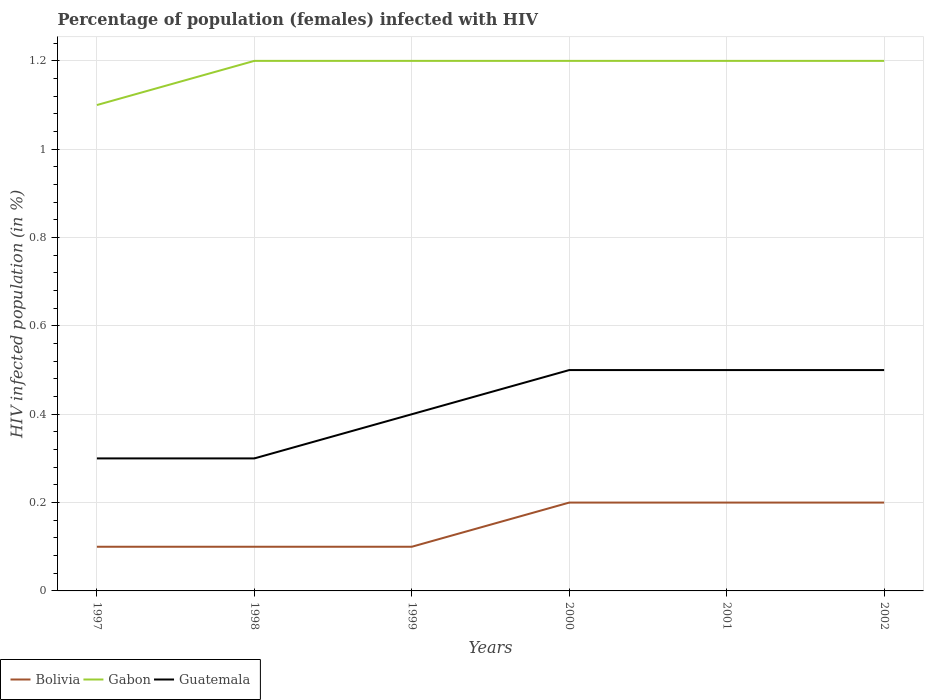Does the line corresponding to Gabon intersect with the line corresponding to Bolivia?
Your answer should be compact. No. Across all years, what is the maximum percentage of HIV infected female population in Guatemala?
Your answer should be very brief. 0.3. In which year was the percentage of HIV infected female population in Guatemala maximum?
Offer a very short reply. 1997. What is the difference between the highest and the lowest percentage of HIV infected female population in Bolivia?
Provide a short and direct response. 3. Are the values on the major ticks of Y-axis written in scientific E-notation?
Give a very brief answer. No. Does the graph contain any zero values?
Make the answer very short. No. Does the graph contain grids?
Give a very brief answer. Yes. How many legend labels are there?
Give a very brief answer. 3. What is the title of the graph?
Give a very brief answer. Percentage of population (females) infected with HIV. What is the label or title of the Y-axis?
Provide a succinct answer. HIV infected population (in %). What is the HIV infected population (in %) in Bolivia in 1997?
Make the answer very short. 0.1. What is the HIV infected population (in %) of Gabon in 1997?
Keep it short and to the point. 1.1. What is the HIV infected population (in %) of Guatemala in 1997?
Make the answer very short. 0.3. What is the HIV infected population (in %) of Gabon in 1998?
Ensure brevity in your answer.  1.2. What is the HIV infected population (in %) in Gabon in 1999?
Make the answer very short. 1.2. What is the HIV infected population (in %) of Guatemala in 1999?
Your answer should be compact. 0.4. What is the HIV infected population (in %) of Gabon in 2000?
Provide a short and direct response. 1.2. What is the HIV infected population (in %) in Guatemala in 2000?
Your answer should be very brief. 0.5. What is the HIV infected population (in %) of Bolivia in 2001?
Offer a terse response. 0.2. What is the HIV infected population (in %) in Bolivia in 2002?
Keep it short and to the point. 0.2. Across all years, what is the maximum HIV infected population (in %) in Bolivia?
Your answer should be very brief. 0.2. Across all years, what is the maximum HIV infected population (in %) in Guatemala?
Offer a terse response. 0.5. Across all years, what is the minimum HIV infected population (in %) in Bolivia?
Make the answer very short. 0.1. Across all years, what is the minimum HIV infected population (in %) of Gabon?
Provide a succinct answer. 1.1. Across all years, what is the minimum HIV infected population (in %) in Guatemala?
Keep it short and to the point. 0.3. What is the total HIV infected population (in %) in Bolivia in the graph?
Provide a short and direct response. 0.9. What is the total HIV infected population (in %) of Guatemala in the graph?
Provide a succinct answer. 2.5. What is the difference between the HIV infected population (in %) of Bolivia in 1997 and that in 1998?
Ensure brevity in your answer.  0. What is the difference between the HIV infected population (in %) in Gabon in 1997 and that in 1998?
Your answer should be very brief. -0.1. What is the difference between the HIV infected population (in %) in Gabon in 1997 and that in 2000?
Provide a succinct answer. -0.1. What is the difference between the HIV infected population (in %) of Guatemala in 1997 and that in 2000?
Offer a terse response. -0.2. What is the difference between the HIV infected population (in %) in Bolivia in 1997 and that in 2001?
Offer a terse response. -0.1. What is the difference between the HIV infected population (in %) in Gabon in 1997 and that in 2001?
Ensure brevity in your answer.  -0.1. What is the difference between the HIV infected population (in %) of Guatemala in 1997 and that in 2001?
Make the answer very short. -0.2. What is the difference between the HIV infected population (in %) of Gabon in 1997 and that in 2002?
Give a very brief answer. -0.1. What is the difference between the HIV infected population (in %) in Gabon in 1998 and that in 1999?
Your response must be concise. 0. What is the difference between the HIV infected population (in %) of Guatemala in 1998 and that in 1999?
Offer a terse response. -0.1. What is the difference between the HIV infected population (in %) of Bolivia in 1998 and that in 2000?
Keep it short and to the point. -0.1. What is the difference between the HIV infected population (in %) of Bolivia in 1998 and that in 2001?
Your answer should be compact. -0.1. What is the difference between the HIV infected population (in %) of Gabon in 1998 and that in 2001?
Make the answer very short. 0. What is the difference between the HIV infected population (in %) of Guatemala in 1998 and that in 2001?
Offer a very short reply. -0.2. What is the difference between the HIV infected population (in %) of Bolivia in 1998 and that in 2002?
Make the answer very short. -0.1. What is the difference between the HIV infected population (in %) in Gabon in 1999 and that in 2001?
Offer a very short reply. 0. What is the difference between the HIV infected population (in %) of Guatemala in 1999 and that in 2001?
Offer a terse response. -0.1. What is the difference between the HIV infected population (in %) in Bolivia in 1999 and that in 2002?
Your answer should be very brief. -0.1. What is the difference between the HIV infected population (in %) in Gabon in 1999 and that in 2002?
Offer a terse response. 0. What is the difference between the HIV infected population (in %) in Gabon in 2000 and that in 2001?
Offer a very short reply. 0. What is the difference between the HIV infected population (in %) of Gabon in 2000 and that in 2002?
Provide a short and direct response. 0. What is the difference between the HIV infected population (in %) in Gabon in 2001 and that in 2002?
Provide a succinct answer. 0. What is the difference between the HIV infected population (in %) in Guatemala in 2001 and that in 2002?
Your answer should be compact. 0. What is the difference between the HIV infected population (in %) of Bolivia in 1997 and the HIV infected population (in %) of Gabon in 1998?
Offer a very short reply. -1.1. What is the difference between the HIV infected population (in %) of Bolivia in 1997 and the HIV infected population (in %) of Gabon in 1999?
Offer a very short reply. -1.1. What is the difference between the HIV infected population (in %) in Bolivia in 1997 and the HIV infected population (in %) in Guatemala in 1999?
Provide a short and direct response. -0.3. What is the difference between the HIV infected population (in %) in Gabon in 1997 and the HIV infected population (in %) in Guatemala in 2000?
Your answer should be very brief. 0.6. What is the difference between the HIV infected population (in %) of Bolivia in 1997 and the HIV infected population (in %) of Gabon in 2001?
Your answer should be very brief. -1.1. What is the difference between the HIV infected population (in %) of Bolivia in 1997 and the HIV infected population (in %) of Guatemala in 2001?
Keep it short and to the point. -0.4. What is the difference between the HIV infected population (in %) in Gabon in 1997 and the HIV infected population (in %) in Guatemala in 2001?
Give a very brief answer. 0.6. What is the difference between the HIV infected population (in %) of Bolivia in 1997 and the HIV infected population (in %) of Gabon in 2002?
Provide a succinct answer. -1.1. What is the difference between the HIV infected population (in %) of Bolivia in 1997 and the HIV infected population (in %) of Guatemala in 2002?
Ensure brevity in your answer.  -0.4. What is the difference between the HIV infected population (in %) of Bolivia in 1998 and the HIV infected population (in %) of Guatemala in 1999?
Your answer should be compact. -0.3. What is the difference between the HIV infected population (in %) in Bolivia in 1998 and the HIV infected population (in %) in Gabon in 2000?
Provide a short and direct response. -1.1. What is the difference between the HIV infected population (in %) in Bolivia in 1998 and the HIV infected population (in %) in Guatemala in 2000?
Give a very brief answer. -0.4. What is the difference between the HIV infected population (in %) of Bolivia in 1998 and the HIV infected population (in %) of Gabon in 2002?
Your response must be concise. -1.1. What is the difference between the HIV infected population (in %) of Gabon in 1999 and the HIV infected population (in %) of Guatemala in 2000?
Give a very brief answer. 0.7. What is the difference between the HIV infected population (in %) in Bolivia in 1999 and the HIV infected population (in %) in Gabon in 2001?
Offer a terse response. -1.1. What is the difference between the HIV infected population (in %) in Gabon in 1999 and the HIV infected population (in %) in Guatemala in 2001?
Offer a terse response. 0.7. What is the difference between the HIV infected population (in %) in Bolivia in 1999 and the HIV infected population (in %) in Gabon in 2002?
Ensure brevity in your answer.  -1.1. What is the difference between the HIV infected population (in %) of Bolivia in 2000 and the HIV infected population (in %) of Gabon in 2001?
Offer a terse response. -1. What is the difference between the HIV infected population (in %) of Bolivia in 2000 and the HIV infected population (in %) of Guatemala in 2001?
Provide a succinct answer. -0.3. What is the difference between the HIV infected population (in %) of Gabon in 2000 and the HIV infected population (in %) of Guatemala in 2001?
Ensure brevity in your answer.  0.7. What is the difference between the HIV infected population (in %) in Bolivia in 2000 and the HIV infected population (in %) in Guatemala in 2002?
Offer a very short reply. -0.3. What is the difference between the HIV infected population (in %) in Gabon in 2000 and the HIV infected population (in %) in Guatemala in 2002?
Your answer should be very brief. 0.7. What is the difference between the HIV infected population (in %) of Bolivia in 2001 and the HIV infected population (in %) of Gabon in 2002?
Offer a very short reply. -1. What is the difference between the HIV infected population (in %) of Bolivia in 2001 and the HIV infected population (in %) of Guatemala in 2002?
Offer a terse response. -0.3. What is the average HIV infected population (in %) of Bolivia per year?
Make the answer very short. 0.15. What is the average HIV infected population (in %) in Gabon per year?
Ensure brevity in your answer.  1.18. What is the average HIV infected population (in %) in Guatemala per year?
Offer a terse response. 0.42. In the year 1997, what is the difference between the HIV infected population (in %) in Bolivia and HIV infected population (in %) in Gabon?
Your answer should be compact. -1. In the year 1997, what is the difference between the HIV infected population (in %) of Gabon and HIV infected population (in %) of Guatemala?
Your answer should be compact. 0.8. In the year 1998, what is the difference between the HIV infected population (in %) in Bolivia and HIV infected population (in %) in Gabon?
Your answer should be compact. -1.1. In the year 1998, what is the difference between the HIV infected population (in %) of Bolivia and HIV infected population (in %) of Guatemala?
Your answer should be compact. -0.2. In the year 1999, what is the difference between the HIV infected population (in %) in Bolivia and HIV infected population (in %) in Guatemala?
Provide a succinct answer. -0.3. In the year 2000, what is the difference between the HIV infected population (in %) in Bolivia and HIV infected population (in %) in Gabon?
Provide a short and direct response. -1. In the year 2000, what is the difference between the HIV infected population (in %) of Bolivia and HIV infected population (in %) of Guatemala?
Give a very brief answer. -0.3. In the year 2000, what is the difference between the HIV infected population (in %) in Gabon and HIV infected population (in %) in Guatemala?
Ensure brevity in your answer.  0.7. In the year 2001, what is the difference between the HIV infected population (in %) in Bolivia and HIV infected population (in %) in Gabon?
Offer a very short reply. -1. In the year 2001, what is the difference between the HIV infected population (in %) of Bolivia and HIV infected population (in %) of Guatemala?
Offer a terse response. -0.3. In the year 2001, what is the difference between the HIV infected population (in %) of Gabon and HIV infected population (in %) of Guatemala?
Your response must be concise. 0.7. In the year 2002, what is the difference between the HIV infected population (in %) of Bolivia and HIV infected population (in %) of Gabon?
Offer a very short reply. -1. In the year 2002, what is the difference between the HIV infected population (in %) of Bolivia and HIV infected population (in %) of Guatemala?
Ensure brevity in your answer.  -0.3. What is the ratio of the HIV infected population (in %) in Bolivia in 1997 to that in 1998?
Your answer should be very brief. 1. What is the ratio of the HIV infected population (in %) in Guatemala in 1997 to that in 1998?
Ensure brevity in your answer.  1. What is the ratio of the HIV infected population (in %) in Bolivia in 1997 to that in 1999?
Your response must be concise. 1. What is the ratio of the HIV infected population (in %) in Bolivia in 1997 to that in 2000?
Make the answer very short. 0.5. What is the ratio of the HIV infected population (in %) of Bolivia in 1997 to that in 2002?
Offer a very short reply. 0.5. What is the ratio of the HIV infected population (in %) in Gabon in 1997 to that in 2002?
Your answer should be compact. 0.92. What is the ratio of the HIV infected population (in %) of Guatemala in 1997 to that in 2002?
Provide a short and direct response. 0.6. What is the ratio of the HIV infected population (in %) of Guatemala in 1998 to that in 1999?
Provide a succinct answer. 0.75. What is the ratio of the HIV infected population (in %) in Bolivia in 1998 to that in 2000?
Your response must be concise. 0.5. What is the ratio of the HIV infected population (in %) of Guatemala in 1998 to that in 2002?
Your answer should be compact. 0.6. What is the ratio of the HIV infected population (in %) in Guatemala in 1999 to that in 2000?
Your answer should be very brief. 0.8. What is the ratio of the HIV infected population (in %) in Bolivia in 1999 to that in 2001?
Give a very brief answer. 0.5. What is the ratio of the HIV infected population (in %) in Gabon in 1999 to that in 2001?
Offer a very short reply. 1. What is the ratio of the HIV infected population (in %) of Guatemala in 1999 to that in 2001?
Provide a short and direct response. 0.8. What is the ratio of the HIV infected population (in %) in Bolivia in 1999 to that in 2002?
Offer a terse response. 0.5. What is the ratio of the HIV infected population (in %) in Guatemala in 1999 to that in 2002?
Your answer should be compact. 0.8. What is the ratio of the HIV infected population (in %) of Guatemala in 2000 to that in 2001?
Your response must be concise. 1. What is the ratio of the HIV infected population (in %) in Bolivia in 2000 to that in 2002?
Your answer should be very brief. 1. What is the ratio of the HIV infected population (in %) in Guatemala in 2000 to that in 2002?
Keep it short and to the point. 1. What is the ratio of the HIV infected population (in %) of Bolivia in 2001 to that in 2002?
Provide a succinct answer. 1. What is the difference between the highest and the second highest HIV infected population (in %) in Bolivia?
Offer a very short reply. 0. What is the difference between the highest and the second highest HIV infected population (in %) in Gabon?
Offer a very short reply. 0. What is the difference between the highest and the second highest HIV infected population (in %) in Guatemala?
Offer a very short reply. 0. What is the difference between the highest and the lowest HIV infected population (in %) of Bolivia?
Ensure brevity in your answer.  0.1. What is the difference between the highest and the lowest HIV infected population (in %) of Guatemala?
Your response must be concise. 0.2. 